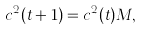Convert formula to latex. <formula><loc_0><loc_0><loc_500><loc_500>c ^ { 2 } ( t + 1 ) = c ^ { 2 } ( t ) M ,</formula> 